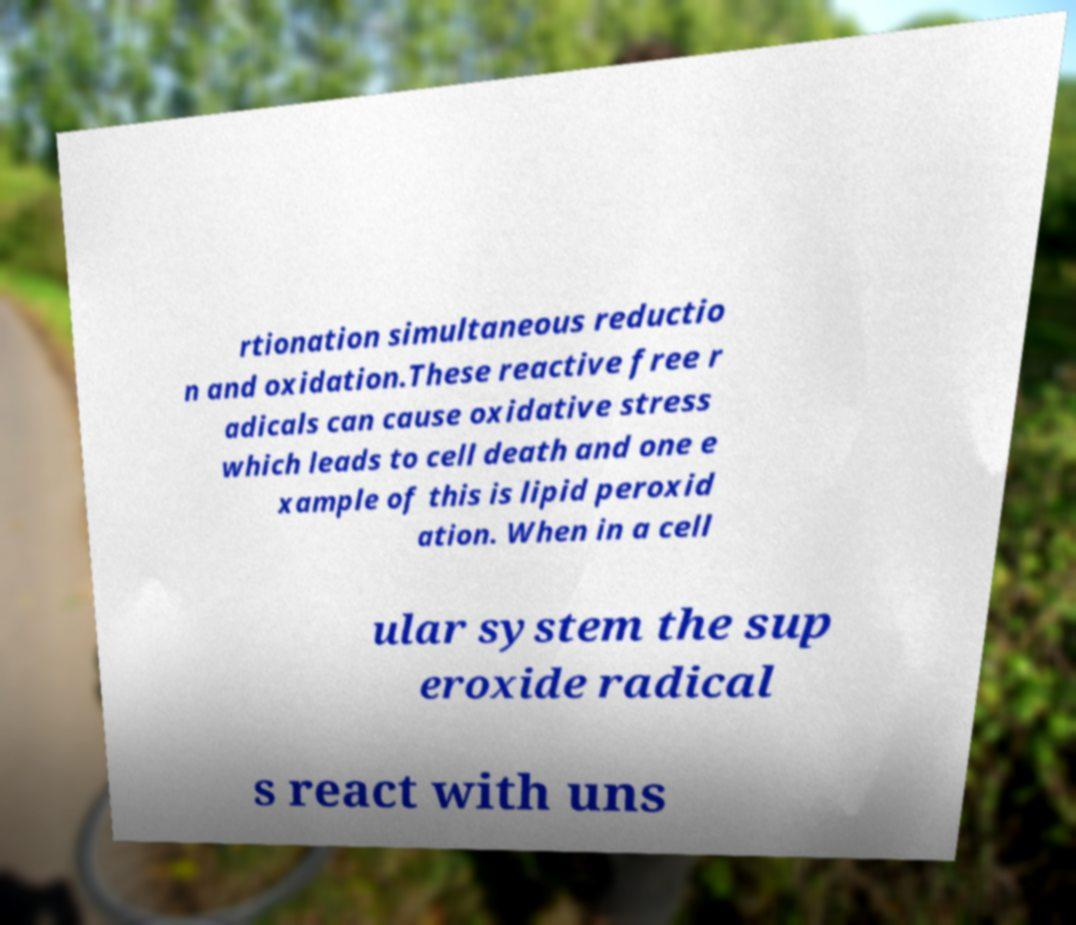Please read and relay the text visible in this image. What does it say? rtionation simultaneous reductio n and oxidation.These reactive free r adicals can cause oxidative stress which leads to cell death and one e xample of this is lipid peroxid ation. When in a cell ular system the sup eroxide radical s react with uns 